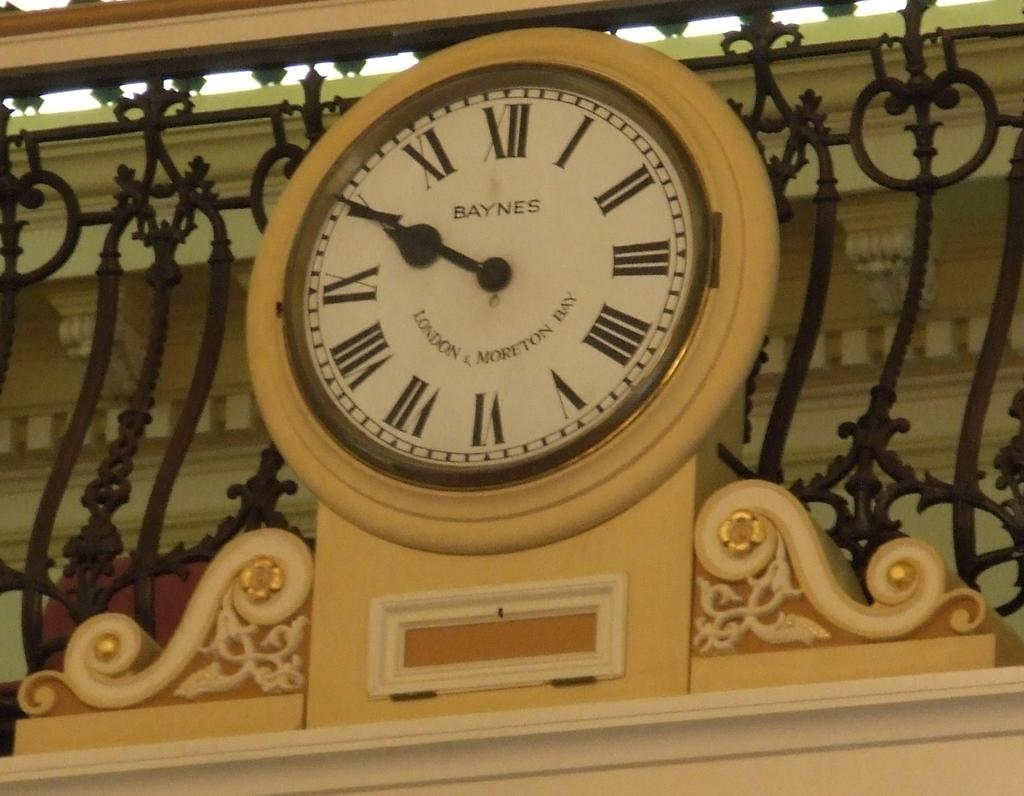<image>
Render a clear and concise summary of the photo. A clock with Roman numerals has the word Baynes in the centre. 